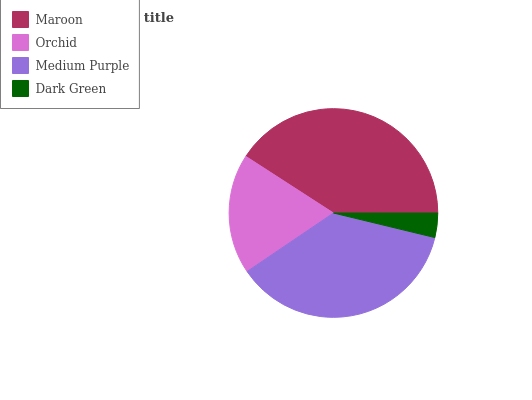Is Dark Green the minimum?
Answer yes or no. Yes. Is Maroon the maximum?
Answer yes or no. Yes. Is Orchid the minimum?
Answer yes or no. No. Is Orchid the maximum?
Answer yes or no. No. Is Maroon greater than Orchid?
Answer yes or no. Yes. Is Orchid less than Maroon?
Answer yes or no. Yes. Is Orchid greater than Maroon?
Answer yes or no. No. Is Maroon less than Orchid?
Answer yes or no. No. Is Medium Purple the high median?
Answer yes or no. Yes. Is Orchid the low median?
Answer yes or no. Yes. Is Dark Green the high median?
Answer yes or no. No. Is Dark Green the low median?
Answer yes or no. No. 